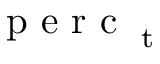<formula> <loc_0><loc_0><loc_500><loc_500>p e r c _ { t }</formula> 